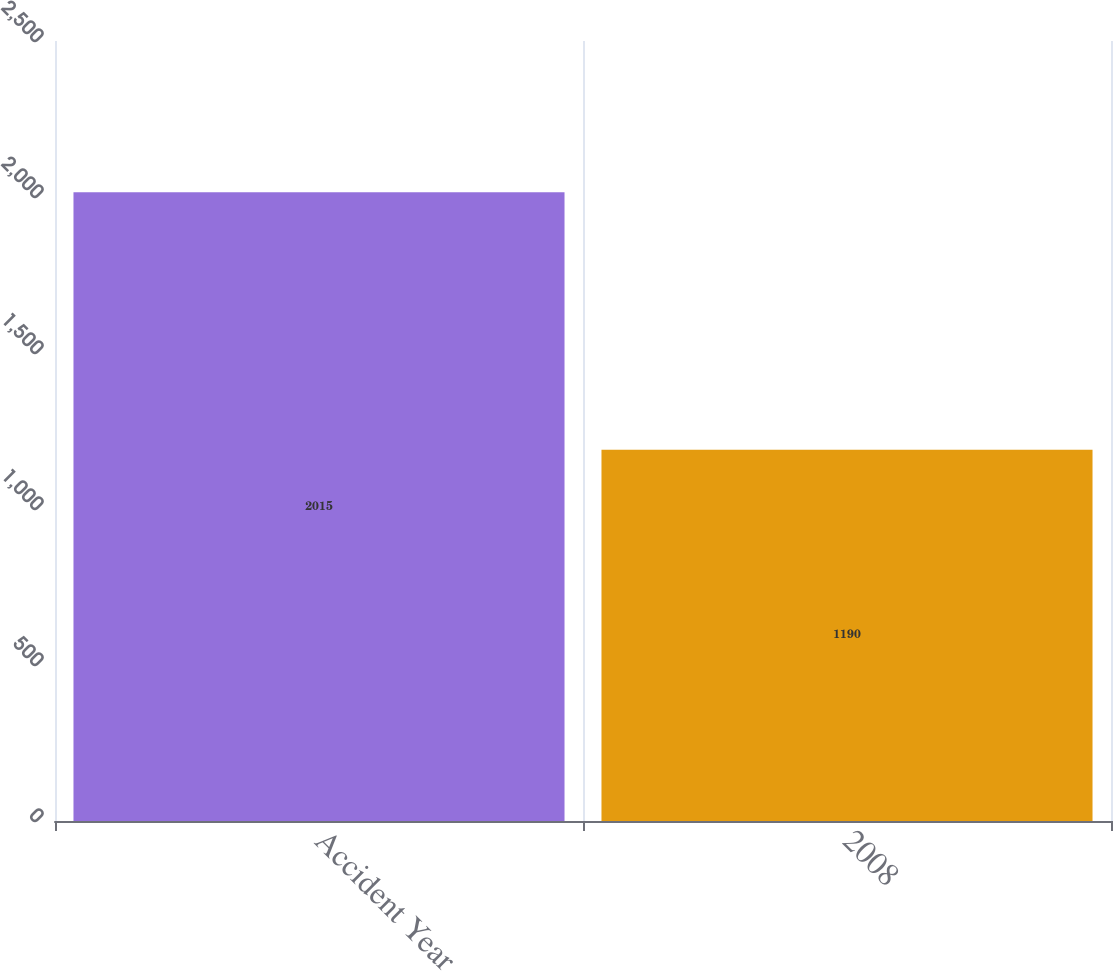<chart> <loc_0><loc_0><loc_500><loc_500><bar_chart><fcel>Accident Year<fcel>2008<nl><fcel>2015<fcel>1190<nl></chart> 